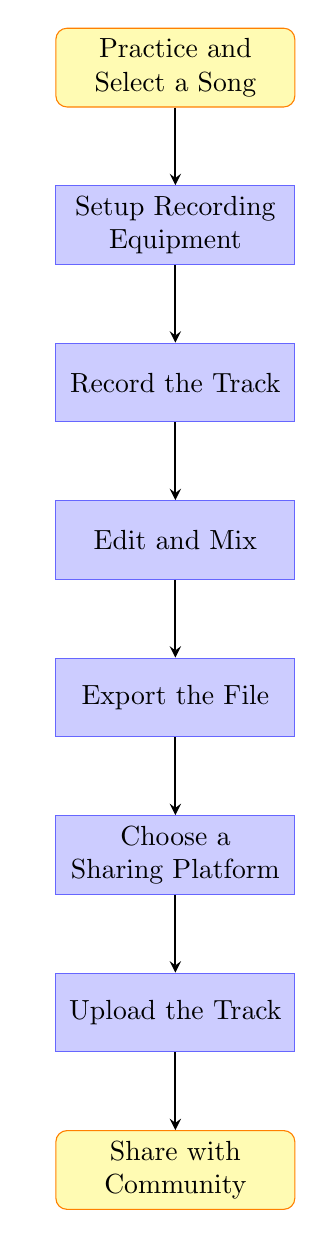What is the first step in the process? The flow chart begins with the node titled "Practice and Select a Song." This node represents the first action to take before any recording can begin.
Answer: Practice and Select a Song How many steps are there in total? The flow chart consists of eight nodes in total, each representing a unique step in the music recording and sharing process.
Answer: Eight What are the last two steps in the process? The last two nodes in the flow chart are "Upload the Track" and "Share with Community." These steps follow the completion of recording and editing.
Answer: Upload the Track, Share with Community What comes after "Edit and Mix"? Following "Edit and Mix," the next step is "Export the File," which involves saving the edited track in a desired audio format.
Answer: Export the File Which step involves selecting a platform? The step where a platform is selected is titled "Choose a Sharing Platform." This occurs after the track has been exported.
Answer: Choose a Sharing Platform Which two steps are directly connected with an arrow from Export the File? The "Export the File" step is directly connected by arrows to the "Choose a Sharing Platform" step and the "Edit and Mix" step. This indicates the progression to share after exporting, and the possibility to return to editing if needed.
Answer: Choose a Sharing Platform, Edit and Mix Which step requires the use of software? The steps "Setup Recording Equipment" and "Edit and Mix" both involve the use of software: recording software for setup and editing software for mixing the track.
Answer: Edit and Mix What is the main purpose of "Share with Community"? The "Share with Community" step focuses on distributing the recorded music to the neighborhood and on social media platforms, aiming to promote the musician's work.
Answer: Share with Community 